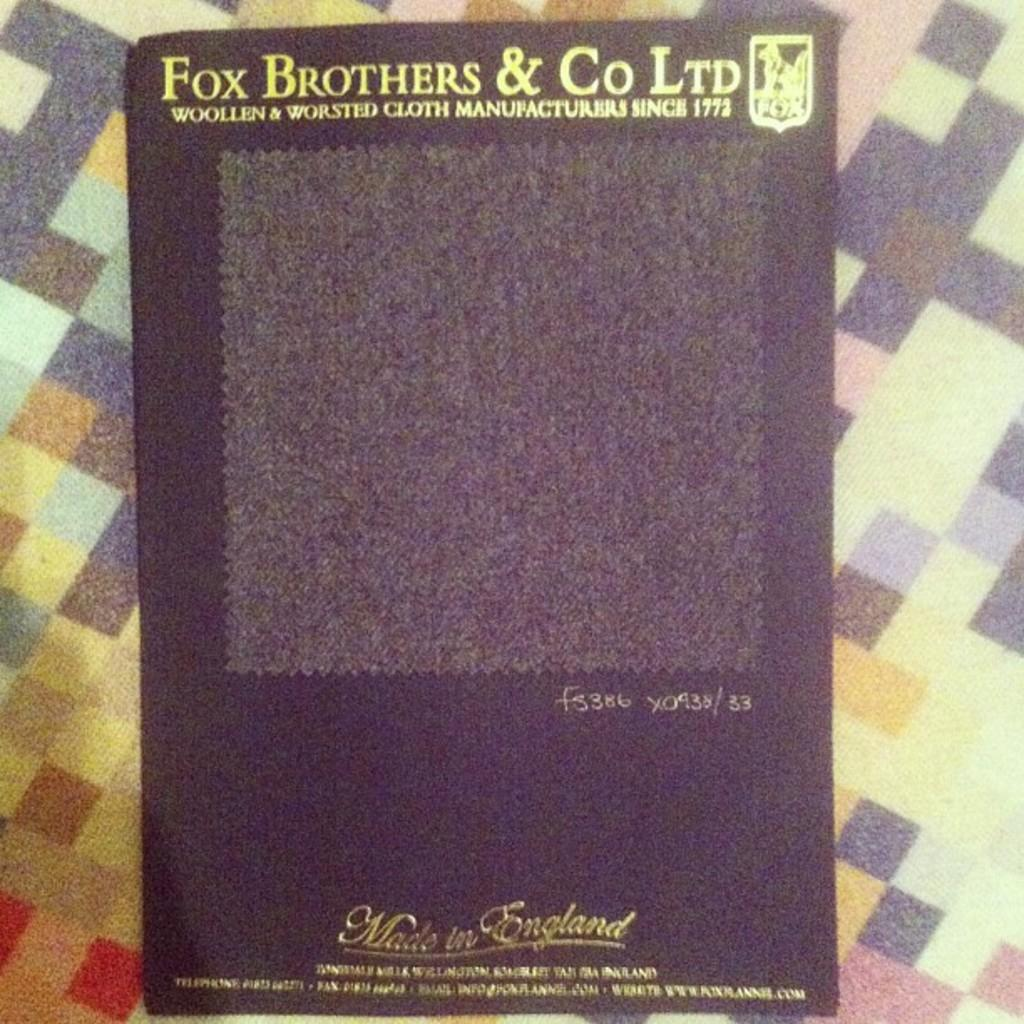<image>
Present a compact description of the photo's key features. A Fox Brothers & Co Ltd Woolen & Worsted Cloth product in black. 